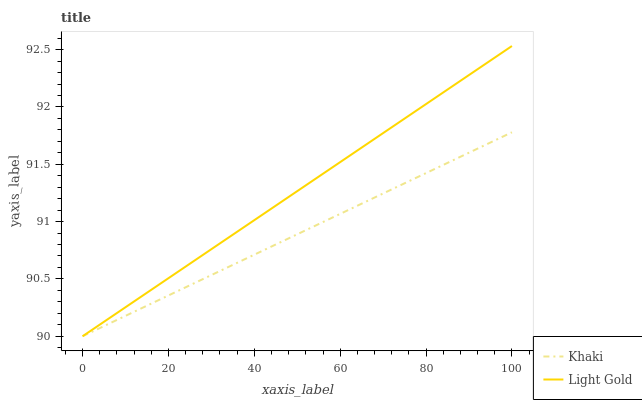Does Khaki have the minimum area under the curve?
Answer yes or no. Yes. Does Light Gold have the maximum area under the curve?
Answer yes or no. Yes. Does Light Gold have the minimum area under the curve?
Answer yes or no. No. Is Light Gold the smoothest?
Answer yes or no. Yes. Is Khaki the roughest?
Answer yes or no. Yes. Is Light Gold the roughest?
Answer yes or no. No. Does Khaki have the lowest value?
Answer yes or no. Yes. Does Light Gold have the highest value?
Answer yes or no. Yes. Does Khaki intersect Light Gold?
Answer yes or no. Yes. Is Khaki less than Light Gold?
Answer yes or no. No. Is Khaki greater than Light Gold?
Answer yes or no. No. 